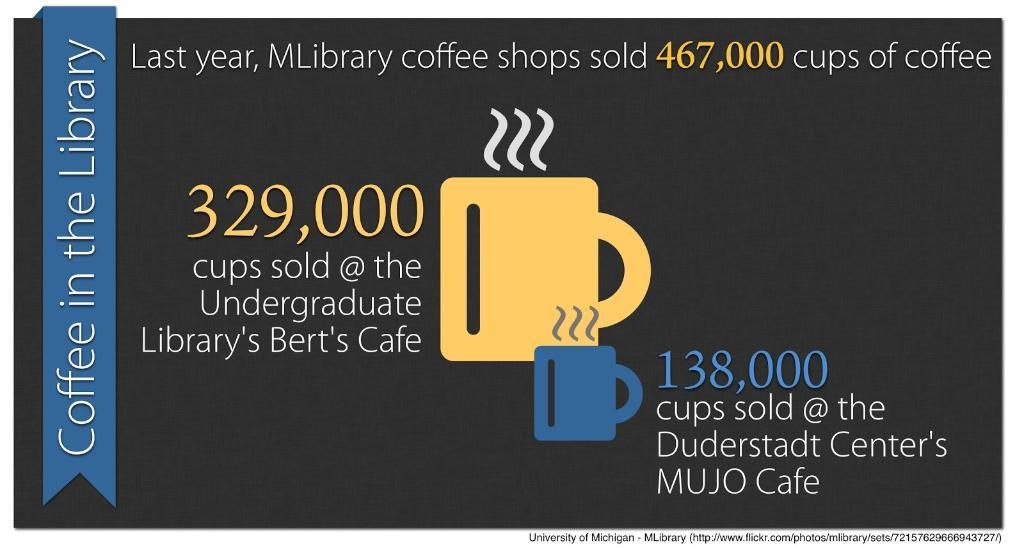<image>
Summarize the visual content of the image. An advertisement is for coffee in the library. 